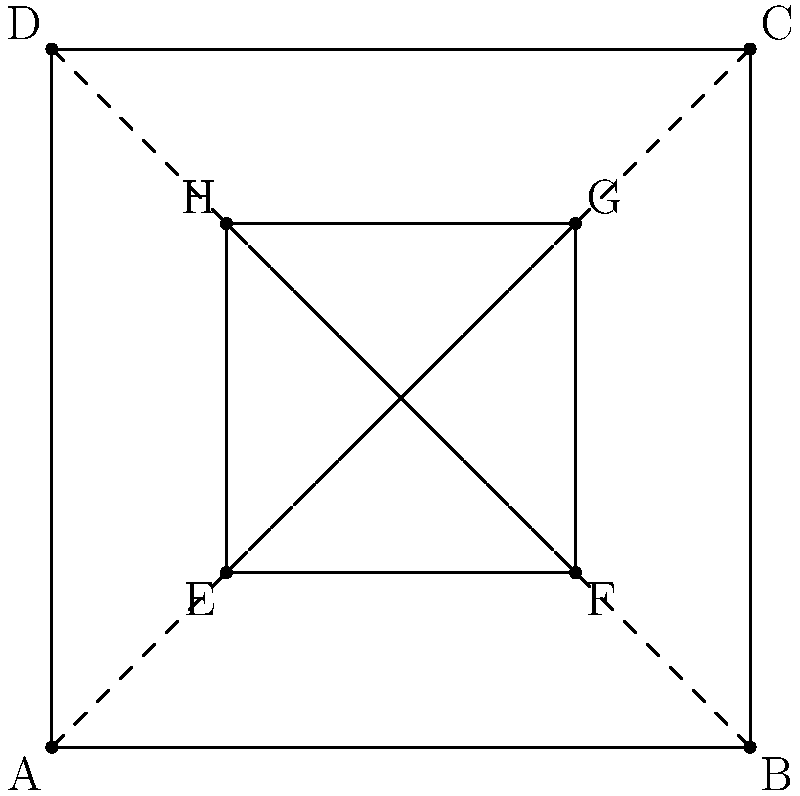In the geometric pattern above, inspired by minimalist fashion trends, how many lines of symmetry does the entire figure have? To determine the number of lines of symmetry in this geometric pattern, we need to analyze the figure step-by-step:

1. The figure consists of two concentric squares: an outer square ABCD and an inner square EFGH.

2. Lines of symmetry in a square:
   a) Diagonal lines connecting opposite corners
   b) Lines passing through the midpoints of opposite sides

3. For the outer square ABCD:
   - Diagonal lines: AC and BD
   - Midpoint lines: vertical line through midpoints of AB and DC, and horizontal line through midpoints of AD and BC

4. For the inner square EFGH:
   - Diagonal lines: EG and FH
   - Midpoint lines: vertical line through midpoints of EF and HG, and horizontal line through midpoints of EH and FG

5. Observe that the lines of symmetry for both squares coincide:
   - The diagonal lines of both squares overlap
   - The midpoint lines of both squares are the same

6. Therefore, the total number of lines of symmetry for the entire figure is:
   - 2 diagonal lines
   - 2 midpoint lines (vertical and horizontal)

Thus, the entire figure has 4 lines of symmetry.
Answer: 4 